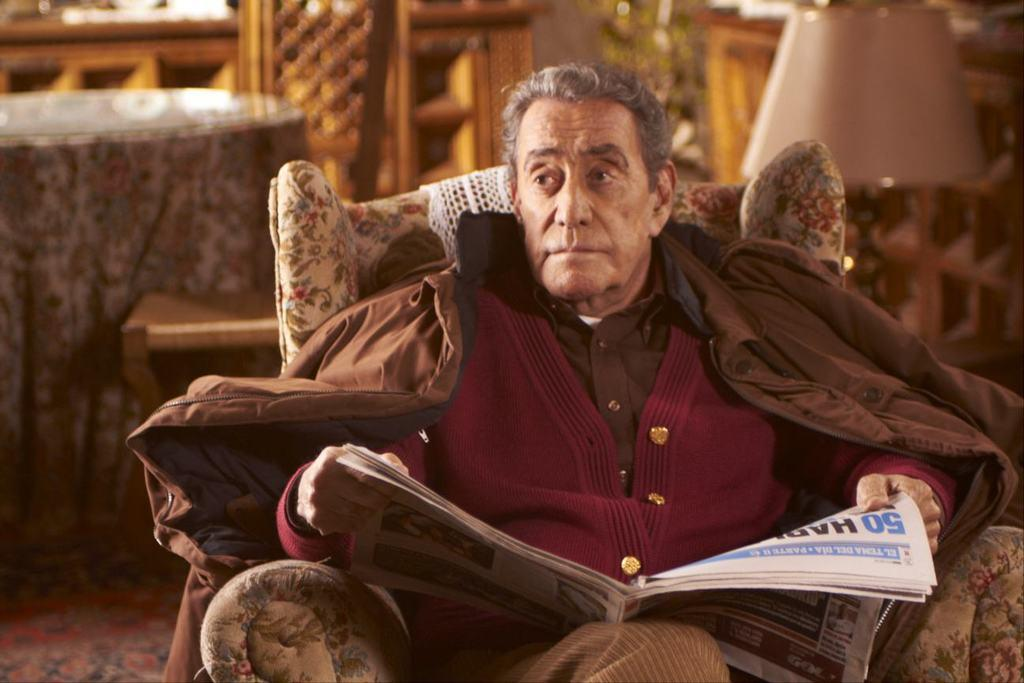Who is present in the image? There is a man in the image. What is the man doing in the image? The man is sitting on a couch in the image. What is the man holding in the image? The man is holding a newspaper in the image. What can be seen in the background of the image? There is a side table, a cupboard, and a plant in the background of the image. What type of cushion is the man sitting on in the image? The provided facts do not mention a cushion, so we cannot determine the type of cushion the man is sitting on. 